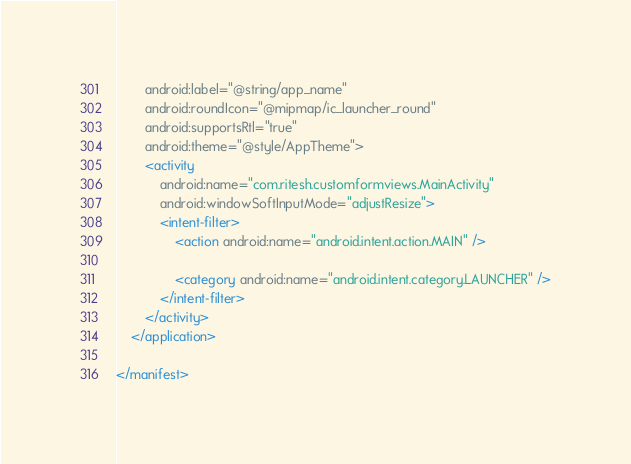<code> <loc_0><loc_0><loc_500><loc_500><_XML_>        android:label="@string/app_name"
        android:roundIcon="@mipmap/ic_launcher_round"
        android:supportsRtl="true"
        android:theme="@style/AppTheme">
        <activity
            android:name="com.ritesh.customformviews.MainActivity"
            android:windowSoftInputMode="adjustResize">
            <intent-filter>
                <action android:name="android.intent.action.MAIN" />

                <category android:name="android.intent.category.LAUNCHER" />
            </intent-filter>
        </activity>
    </application>

</manifest></code> 